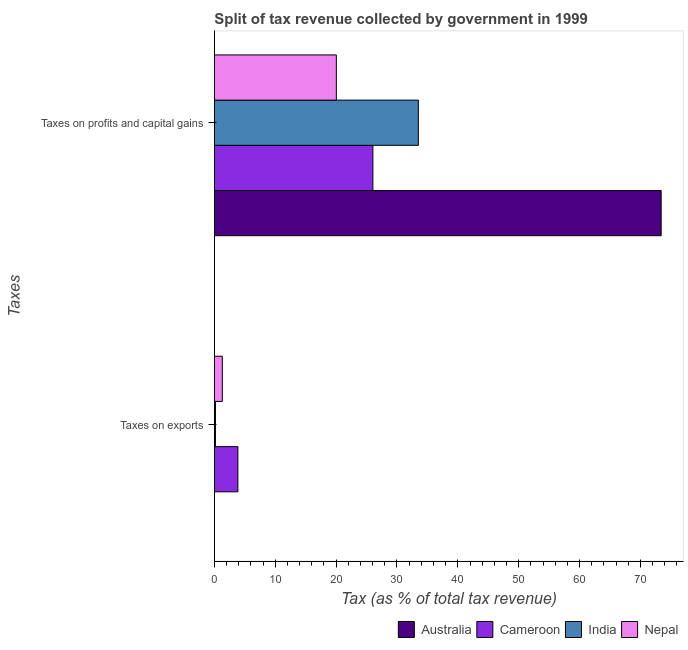Are the number of bars on each tick of the Y-axis equal?
Make the answer very short. Yes. What is the label of the 1st group of bars from the top?
Give a very brief answer. Taxes on profits and capital gains. What is the percentage of revenue obtained from taxes on exports in Australia?
Offer a terse response. 0. Across all countries, what is the maximum percentage of revenue obtained from taxes on profits and capital gains?
Make the answer very short. 73.4. Across all countries, what is the minimum percentage of revenue obtained from taxes on exports?
Provide a succinct answer. 0. In which country was the percentage of revenue obtained from taxes on profits and capital gains minimum?
Give a very brief answer. Nepal. What is the total percentage of revenue obtained from taxes on exports in the graph?
Give a very brief answer. 5.37. What is the difference between the percentage of revenue obtained from taxes on exports in Nepal and that in Australia?
Your answer should be compact. 1.31. What is the difference between the percentage of revenue obtained from taxes on profits and capital gains in Nepal and the percentage of revenue obtained from taxes on exports in India?
Ensure brevity in your answer.  19.86. What is the average percentage of revenue obtained from taxes on profits and capital gains per country?
Offer a very short reply. 38.25. What is the difference between the percentage of revenue obtained from taxes on exports and percentage of revenue obtained from taxes on profits and capital gains in Australia?
Provide a short and direct response. -73.4. What is the ratio of the percentage of revenue obtained from taxes on exports in Nepal to that in Australia?
Offer a very short reply. 457.21. In how many countries, is the percentage of revenue obtained from taxes on exports greater than the average percentage of revenue obtained from taxes on exports taken over all countries?
Provide a short and direct response. 1. What does the 3rd bar from the top in Taxes on exports represents?
Your answer should be compact. Cameroon. What does the 1st bar from the bottom in Taxes on exports represents?
Your answer should be very brief. Australia. How many countries are there in the graph?
Your response must be concise. 4. What is the difference between two consecutive major ticks on the X-axis?
Offer a very short reply. 10. Are the values on the major ticks of X-axis written in scientific E-notation?
Give a very brief answer. No. Does the graph contain any zero values?
Your answer should be compact. No. What is the title of the graph?
Your answer should be very brief. Split of tax revenue collected by government in 1999. What is the label or title of the X-axis?
Offer a very short reply. Tax (as % of total tax revenue). What is the label or title of the Y-axis?
Offer a terse response. Taxes. What is the Tax (as % of total tax revenue) of Australia in Taxes on exports?
Your answer should be very brief. 0. What is the Tax (as % of total tax revenue) in Cameroon in Taxes on exports?
Offer a terse response. 3.87. What is the Tax (as % of total tax revenue) of India in Taxes on exports?
Offer a terse response. 0.18. What is the Tax (as % of total tax revenue) of Nepal in Taxes on exports?
Give a very brief answer. 1.31. What is the Tax (as % of total tax revenue) of Australia in Taxes on profits and capital gains?
Your response must be concise. 73.4. What is the Tax (as % of total tax revenue) of Cameroon in Taxes on profits and capital gains?
Your answer should be compact. 26.05. What is the Tax (as % of total tax revenue) of India in Taxes on profits and capital gains?
Offer a terse response. 33.51. What is the Tax (as % of total tax revenue) of Nepal in Taxes on profits and capital gains?
Provide a succinct answer. 20.04. Across all Taxes, what is the maximum Tax (as % of total tax revenue) in Australia?
Provide a succinct answer. 73.4. Across all Taxes, what is the maximum Tax (as % of total tax revenue) in Cameroon?
Offer a terse response. 26.05. Across all Taxes, what is the maximum Tax (as % of total tax revenue) of India?
Keep it short and to the point. 33.51. Across all Taxes, what is the maximum Tax (as % of total tax revenue) in Nepal?
Ensure brevity in your answer.  20.04. Across all Taxes, what is the minimum Tax (as % of total tax revenue) in Australia?
Offer a terse response. 0. Across all Taxes, what is the minimum Tax (as % of total tax revenue) in Cameroon?
Provide a succinct answer. 3.87. Across all Taxes, what is the minimum Tax (as % of total tax revenue) in India?
Give a very brief answer. 0.18. Across all Taxes, what is the minimum Tax (as % of total tax revenue) in Nepal?
Provide a succinct answer. 1.31. What is the total Tax (as % of total tax revenue) of Australia in the graph?
Your response must be concise. 73.41. What is the total Tax (as % of total tax revenue) in Cameroon in the graph?
Provide a short and direct response. 29.91. What is the total Tax (as % of total tax revenue) of India in the graph?
Provide a succinct answer. 33.69. What is the total Tax (as % of total tax revenue) of Nepal in the graph?
Provide a succinct answer. 21.36. What is the difference between the Tax (as % of total tax revenue) in Australia in Taxes on exports and that in Taxes on profits and capital gains?
Your answer should be very brief. -73.4. What is the difference between the Tax (as % of total tax revenue) in Cameroon in Taxes on exports and that in Taxes on profits and capital gains?
Make the answer very short. -22.18. What is the difference between the Tax (as % of total tax revenue) in India in Taxes on exports and that in Taxes on profits and capital gains?
Give a very brief answer. -33.33. What is the difference between the Tax (as % of total tax revenue) in Nepal in Taxes on exports and that in Taxes on profits and capital gains?
Offer a terse response. -18.73. What is the difference between the Tax (as % of total tax revenue) in Australia in Taxes on exports and the Tax (as % of total tax revenue) in Cameroon in Taxes on profits and capital gains?
Your answer should be very brief. -26.04. What is the difference between the Tax (as % of total tax revenue) in Australia in Taxes on exports and the Tax (as % of total tax revenue) in India in Taxes on profits and capital gains?
Your answer should be very brief. -33.51. What is the difference between the Tax (as % of total tax revenue) of Australia in Taxes on exports and the Tax (as % of total tax revenue) of Nepal in Taxes on profits and capital gains?
Your answer should be compact. -20.04. What is the difference between the Tax (as % of total tax revenue) of Cameroon in Taxes on exports and the Tax (as % of total tax revenue) of India in Taxes on profits and capital gains?
Your response must be concise. -29.64. What is the difference between the Tax (as % of total tax revenue) of Cameroon in Taxes on exports and the Tax (as % of total tax revenue) of Nepal in Taxes on profits and capital gains?
Your answer should be very brief. -16.17. What is the difference between the Tax (as % of total tax revenue) of India in Taxes on exports and the Tax (as % of total tax revenue) of Nepal in Taxes on profits and capital gains?
Your response must be concise. -19.86. What is the average Tax (as % of total tax revenue) of Australia per Taxes?
Your response must be concise. 36.7. What is the average Tax (as % of total tax revenue) in Cameroon per Taxes?
Provide a succinct answer. 14.96. What is the average Tax (as % of total tax revenue) of India per Taxes?
Your response must be concise. 16.85. What is the average Tax (as % of total tax revenue) in Nepal per Taxes?
Your response must be concise. 10.68. What is the difference between the Tax (as % of total tax revenue) in Australia and Tax (as % of total tax revenue) in Cameroon in Taxes on exports?
Offer a terse response. -3.87. What is the difference between the Tax (as % of total tax revenue) of Australia and Tax (as % of total tax revenue) of India in Taxes on exports?
Provide a succinct answer. -0.18. What is the difference between the Tax (as % of total tax revenue) in Australia and Tax (as % of total tax revenue) in Nepal in Taxes on exports?
Your answer should be very brief. -1.31. What is the difference between the Tax (as % of total tax revenue) in Cameroon and Tax (as % of total tax revenue) in India in Taxes on exports?
Provide a short and direct response. 3.69. What is the difference between the Tax (as % of total tax revenue) of Cameroon and Tax (as % of total tax revenue) of Nepal in Taxes on exports?
Offer a terse response. 2.56. What is the difference between the Tax (as % of total tax revenue) of India and Tax (as % of total tax revenue) of Nepal in Taxes on exports?
Give a very brief answer. -1.13. What is the difference between the Tax (as % of total tax revenue) of Australia and Tax (as % of total tax revenue) of Cameroon in Taxes on profits and capital gains?
Offer a terse response. 47.36. What is the difference between the Tax (as % of total tax revenue) in Australia and Tax (as % of total tax revenue) in India in Taxes on profits and capital gains?
Ensure brevity in your answer.  39.89. What is the difference between the Tax (as % of total tax revenue) in Australia and Tax (as % of total tax revenue) in Nepal in Taxes on profits and capital gains?
Give a very brief answer. 53.36. What is the difference between the Tax (as % of total tax revenue) in Cameroon and Tax (as % of total tax revenue) in India in Taxes on profits and capital gains?
Offer a terse response. -7.47. What is the difference between the Tax (as % of total tax revenue) in Cameroon and Tax (as % of total tax revenue) in Nepal in Taxes on profits and capital gains?
Offer a very short reply. 6. What is the difference between the Tax (as % of total tax revenue) of India and Tax (as % of total tax revenue) of Nepal in Taxes on profits and capital gains?
Ensure brevity in your answer.  13.47. What is the ratio of the Tax (as % of total tax revenue) of Australia in Taxes on exports to that in Taxes on profits and capital gains?
Your response must be concise. 0. What is the ratio of the Tax (as % of total tax revenue) in Cameroon in Taxes on exports to that in Taxes on profits and capital gains?
Ensure brevity in your answer.  0.15. What is the ratio of the Tax (as % of total tax revenue) in India in Taxes on exports to that in Taxes on profits and capital gains?
Ensure brevity in your answer.  0.01. What is the ratio of the Tax (as % of total tax revenue) of Nepal in Taxes on exports to that in Taxes on profits and capital gains?
Ensure brevity in your answer.  0.07. What is the difference between the highest and the second highest Tax (as % of total tax revenue) in Australia?
Provide a succinct answer. 73.4. What is the difference between the highest and the second highest Tax (as % of total tax revenue) of Cameroon?
Keep it short and to the point. 22.18. What is the difference between the highest and the second highest Tax (as % of total tax revenue) of India?
Offer a terse response. 33.33. What is the difference between the highest and the second highest Tax (as % of total tax revenue) of Nepal?
Give a very brief answer. 18.73. What is the difference between the highest and the lowest Tax (as % of total tax revenue) in Australia?
Provide a succinct answer. 73.4. What is the difference between the highest and the lowest Tax (as % of total tax revenue) in Cameroon?
Offer a very short reply. 22.18. What is the difference between the highest and the lowest Tax (as % of total tax revenue) in India?
Make the answer very short. 33.33. What is the difference between the highest and the lowest Tax (as % of total tax revenue) of Nepal?
Provide a succinct answer. 18.73. 